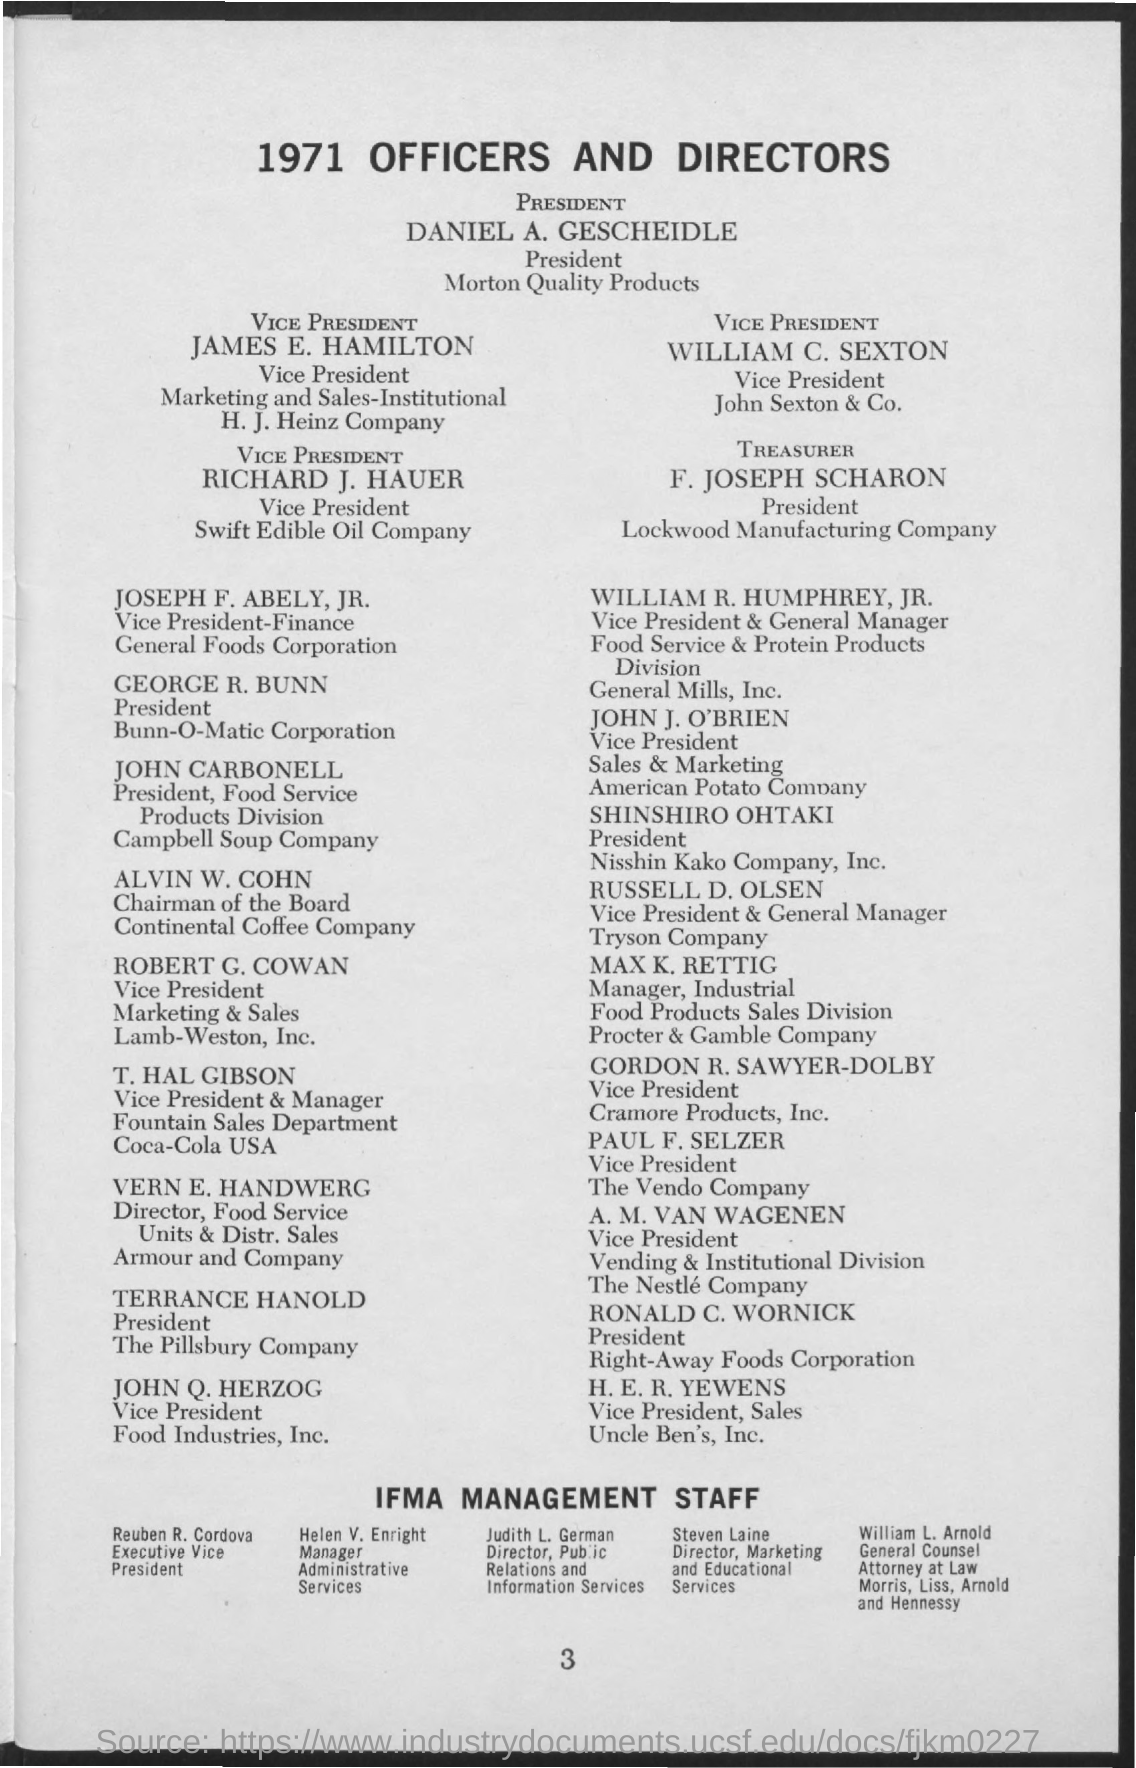Specify some key components in this picture. What is the title of the document that was created in 1971? It is called 1971 OFFICERS AND DIRECTORS. 